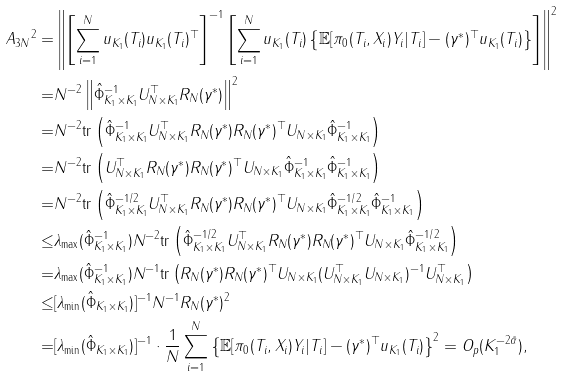Convert formula to latex. <formula><loc_0><loc_0><loc_500><loc_500>\| A _ { 3 N } \| ^ { 2 } = & \left \| \left [ \sum _ { i = 1 } ^ { N } u _ { K _ { 1 } } ( T _ { i } ) u _ { K _ { 1 } } ( T _ { i } ) ^ { \top } \right ] ^ { - 1 } \left [ \sum _ { i = 1 } ^ { N } u _ { K _ { 1 } } ( T _ { i } ) \left \{ \mathbb { E } [ { \pi } _ { 0 } ( T _ { i } , X _ { i } ) Y _ { i } | T _ { i } ] - ( \gamma ^ { * } ) ^ { \top } u _ { K _ { 1 } } ( T _ { i } ) \right \} \right ] \right \| ^ { 2 } \\ = & N ^ { - 2 } \left \| \hat { \Phi } _ { K _ { 1 } \times K _ { 1 } } ^ { - 1 } U _ { N \times K _ { 1 } } ^ { \top } R _ { N } ( \gamma ^ { * } ) \right \| ^ { 2 } \\ = & N ^ { - 2 } \text {tr} \left ( \hat { \Phi } _ { K _ { 1 } \times K _ { 1 } } ^ { - 1 } U _ { N \times K _ { 1 } } ^ { \top } R _ { N } ( \gamma ^ { * } ) R _ { N } ( \gamma ^ { * } ) ^ { \top } U _ { N \times K _ { 1 } } \hat { \Phi } _ { K _ { 1 } \times K _ { 1 } } ^ { - 1 } \right ) \\ = & N ^ { - 2 } \text {tr} \left ( U _ { N \times K _ { 1 } } ^ { \top } R _ { N } ( \gamma ^ { * } ) R _ { N } ( \gamma ^ { * } ) ^ { \top } U _ { N \times K _ { 1 } } \hat { \Phi } _ { K _ { 1 } \times K _ { 1 } } ^ { - 1 } \hat { \Phi } _ { K _ { 1 } \times K _ { 1 } } ^ { - 1 } \right ) \\ = & N ^ { - 2 } \text {tr} \left ( \hat { \Phi } _ { K _ { 1 } \times K _ { 1 } } ^ { - 1 / 2 } U _ { N \times K _ { 1 } } ^ { \top } R _ { N } ( \gamma ^ { * } ) R _ { N } ( \gamma ^ { * } ) ^ { \top } U _ { N \times K _ { 1 } } \hat { \Phi } _ { K _ { 1 } \times K _ { 1 } } ^ { - 1 / 2 } \hat { \Phi } _ { K _ { 1 } \times K _ { 1 } } ^ { - 1 } \right ) \\ \leq & \lambda _ { \max } ( \hat { \Phi } _ { K _ { 1 } \times K _ { 1 } } ^ { - 1 } ) N ^ { - 2 } \text {tr} \left ( \hat { \Phi } _ { K _ { 1 } \times K _ { 1 } } ^ { - 1 / 2 } U _ { N \times K _ { 1 } } ^ { \top } R _ { N } ( \gamma ^ { * } ) R _ { N } ( \gamma ^ { * } ) ^ { \top } U _ { N \times K _ { 1 } } \hat { \Phi } _ { K _ { 1 } \times K _ { 1 } } ^ { - 1 / 2 } \right ) \\ = & \lambda _ { \max } ( \hat { \Phi } _ { K _ { 1 } \times K _ { 1 } } ^ { - 1 } ) N ^ { - 1 } \text {tr} \left ( R _ { N } ( \gamma ^ { * } ) R _ { N } ( \gamma ^ { * } ) ^ { \top } U _ { N \times K _ { 1 } } ( U ^ { \top } _ { N \times K _ { 1 } } U _ { N \times K _ { 1 } } ) ^ { - 1 } U _ { N \times K _ { 1 } } ^ { \top } \right ) \\ \leq & [ \lambda _ { \min } ( \hat { \Phi } _ { K _ { 1 } \times K _ { 1 } } ) ] ^ { - 1 } N ^ { - 1 } \| R _ { N } ( \gamma ^ { * } ) \| ^ { 2 } \\ = & [ \lambda _ { \min } ( \hat { \Phi } _ { K _ { 1 } \times K _ { 1 } } ) ] ^ { - 1 } \cdot \frac { 1 } { N } \sum _ { i = 1 } ^ { N } \left \{ \mathbb { E } [ { \pi } _ { 0 } ( T _ { i } , X _ { i } ) Y _ { i } | T _ { i } ] - ( \gamma ^ { * } ) ^ { \top } u _ { K _ { 1 } } ( T _ { i } ) \right \} ^ { 2 } = O _ { p } ( K _ { 1 } ^ { - 2 \tilde { \alpha } } ) ,</formula> 